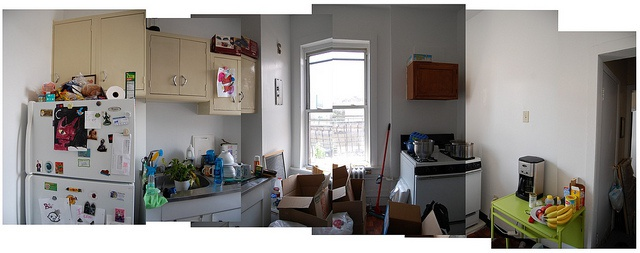Describe the objects in this image and their specific colors. I can see refrigerator in white, darkgray, black, gray, and maroon tones, oven in white, black, gray, and darkgray tones, backpack in white, black, and gray tones, potted plant in white, black, gray, and darkgreen tones, and banana in white and olive tones in this image. 